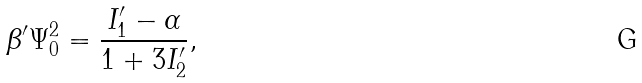<formula> <loc_0><loc_0><loc_500><loc_500>\beta ^ { \prime } \Psi _ { 0 } ^ { 2 } = \frac { I ^ { \prime } _ { 1 } - \alpha } { 1 + 3 I ^ { \prime } _ { 2 } } ,</formula> 